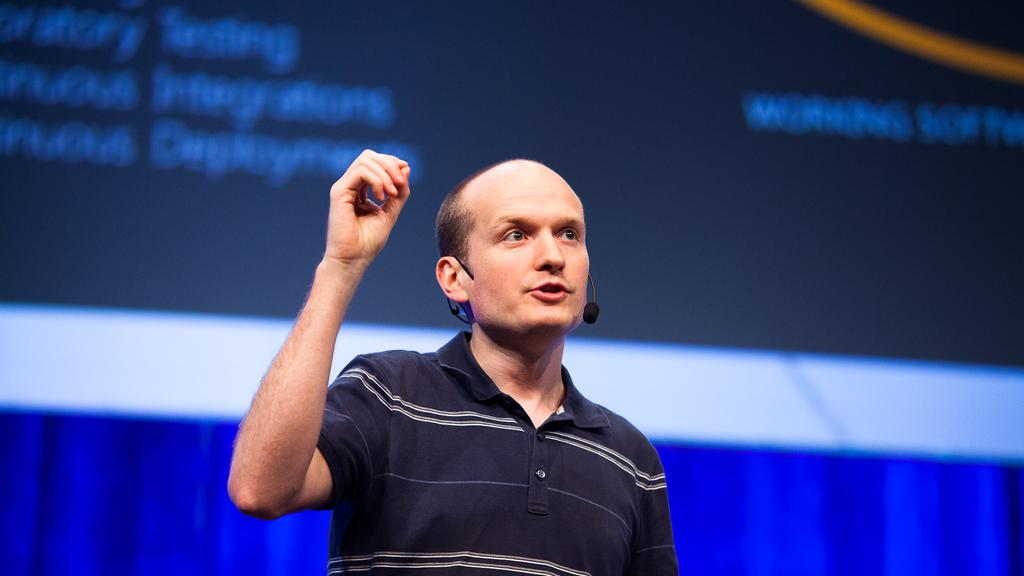Who is the main subject in the image? There is a man in the image. What is the man doing in the image? The man is talking on a microphone. What can be seen in the background of the image? There is a cloth and a banner in the background of the image. How does the fog affect the man's speech in the image? There is no fog present in the image, so it does not affect the man's speech. What type of milk is being served in the image? There is no milk present in the image. 